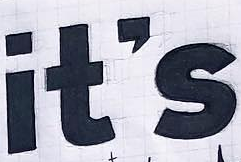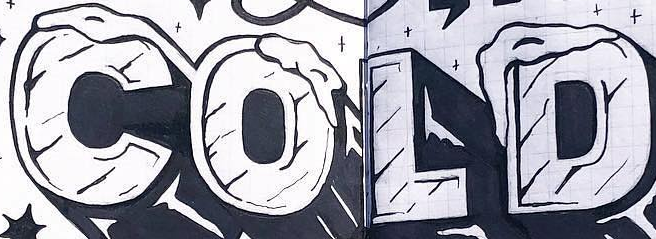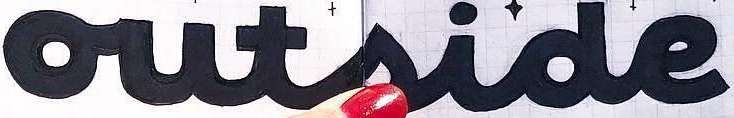What text appears in these images from left to right, separated by a semicolon? it's; COLD; outside 